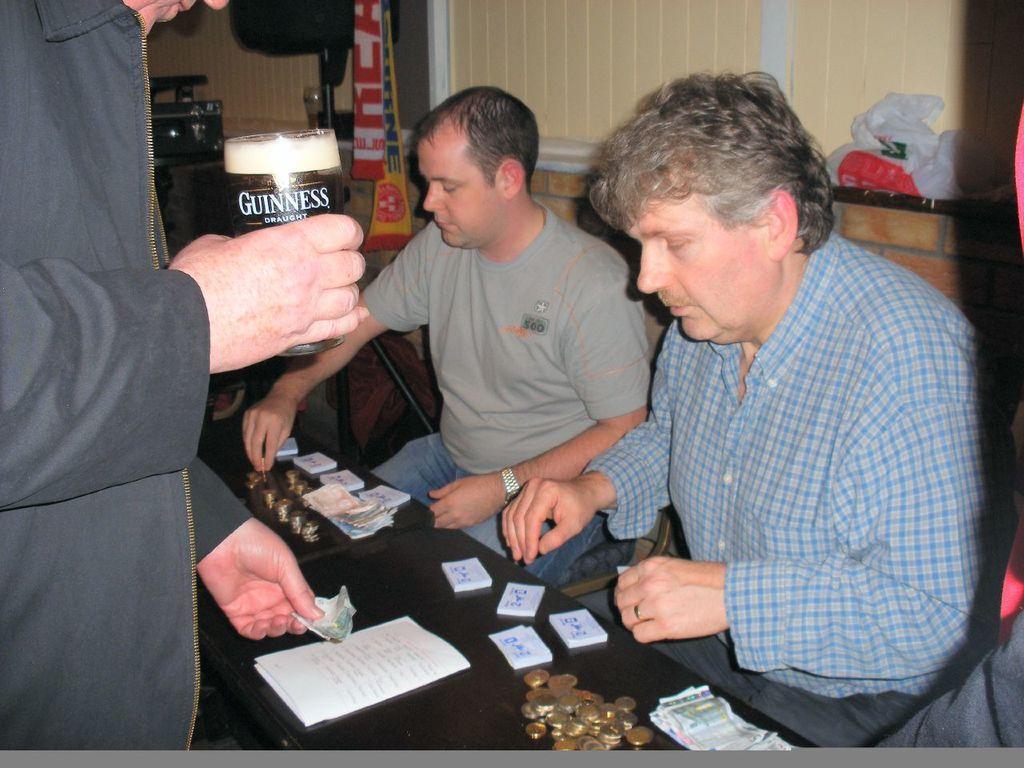How would you summarize this image in a sentence or two? In this image two persons are sitting. Before them there is a table having few cards, coins, papers are on it. Left side there is a person holding a glass with one hand. Money with other hand. The glass is filled with drink. Right side there are few covers kept near the window which is covered with curtain. 